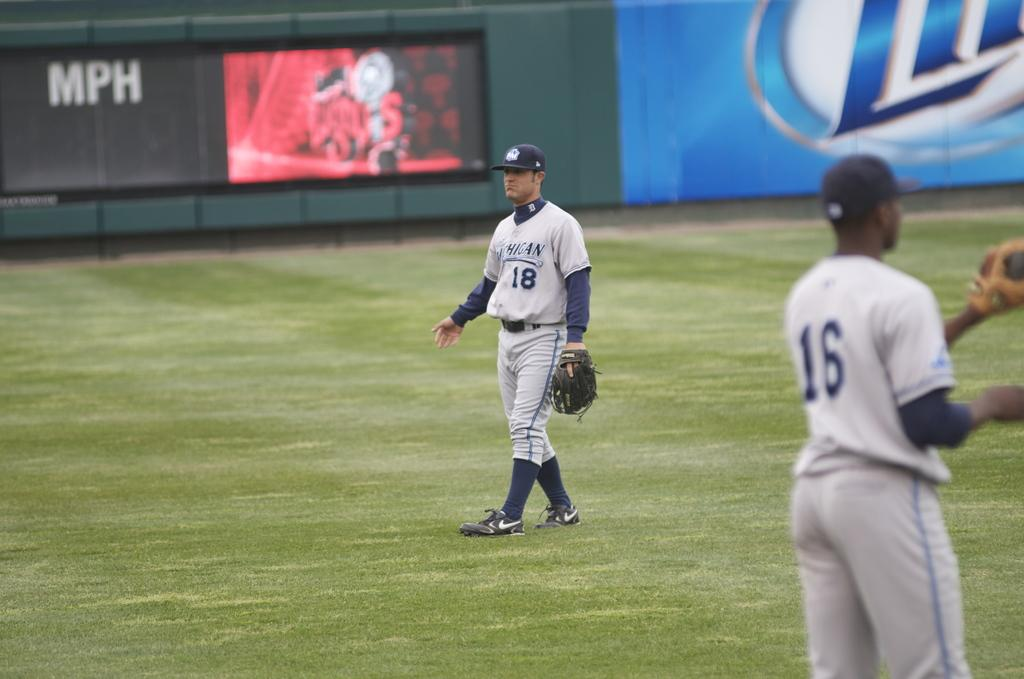<image>
Give a short and clear explanation of the subsequent image. A baseball player with the number 18 on his top and another with the number 16 on his stand in front of a large screen and the letters MPH 